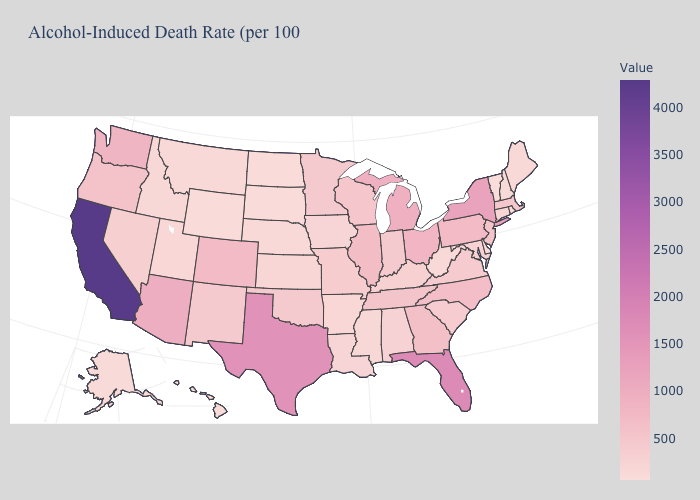Does Delaware have the highest value in the USA?
Be succinct. No. Among the states that border Massachusetts , which have the lowest value?
Concise answer only. Vermont. Does the map have missing data?
Keep it brief. No. Does the map have missing data?
Keep it brief. No. Among the states that border Connecticut , which have the highest value?
Quick response, please. New York. Does North Carolina have a lower value than Arkansas?
Quick response, please. No. Is the legend a continuous bar?
Short answer required. Yes. Which states have the lowest value in the South?
Keep it brief. Delaware. Which states have the highest value in the USA?
Concise answer only. California. Among the states that border Texas , does Arkansas have the lowest value?
Short answer required. Yes. Does the map have missing data?
Short answer required. No. Which states have the lowest value in the USA?
Keep it brief. Vermont. 